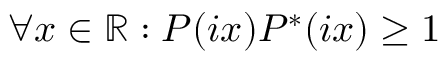Convert formula to latex. <formula><loc_0><loc_0><loc_500><loc_500>\forall x \in \mathbb { R } \colon P ( i x ) P ^ { * } ( i x ) \geq 1</formula> 